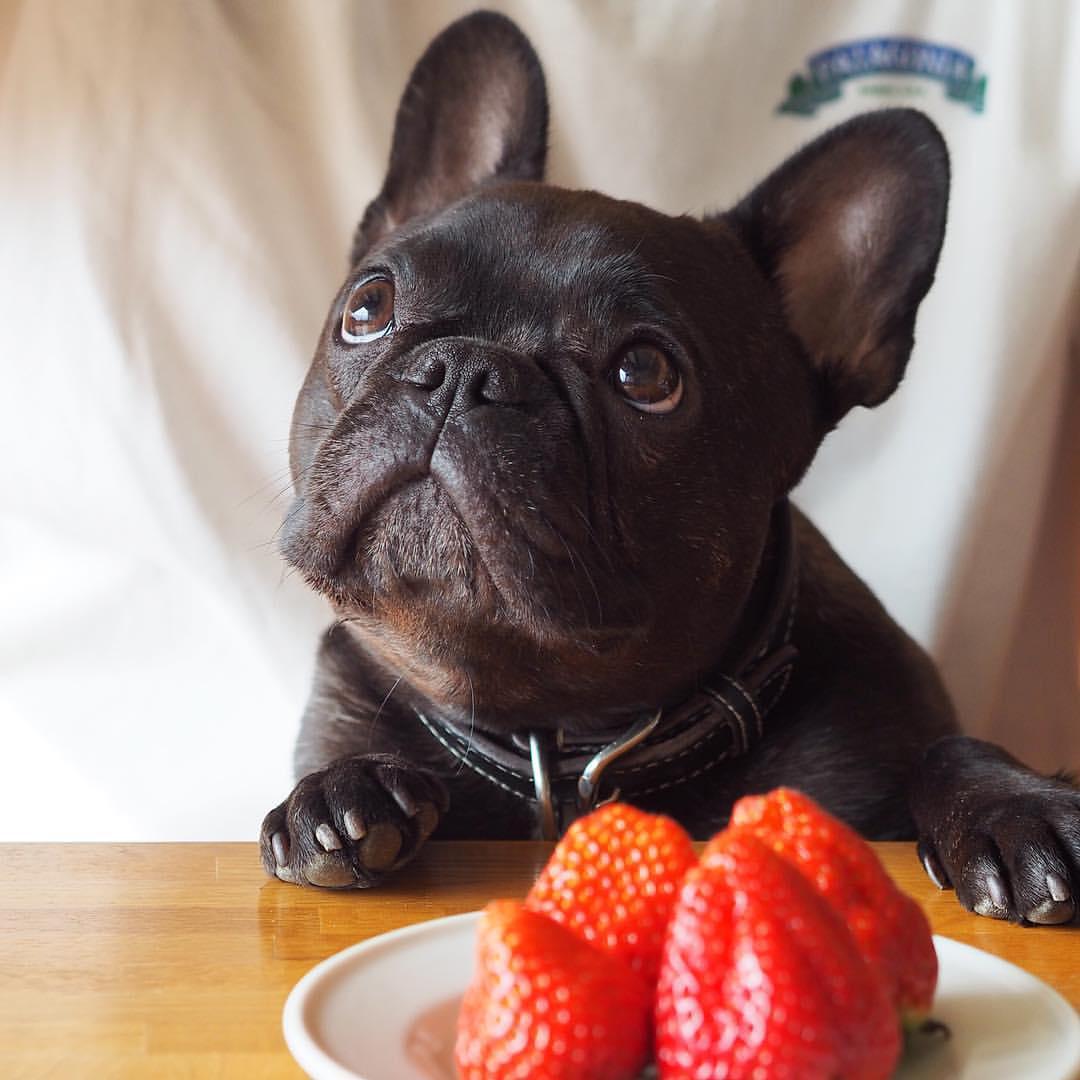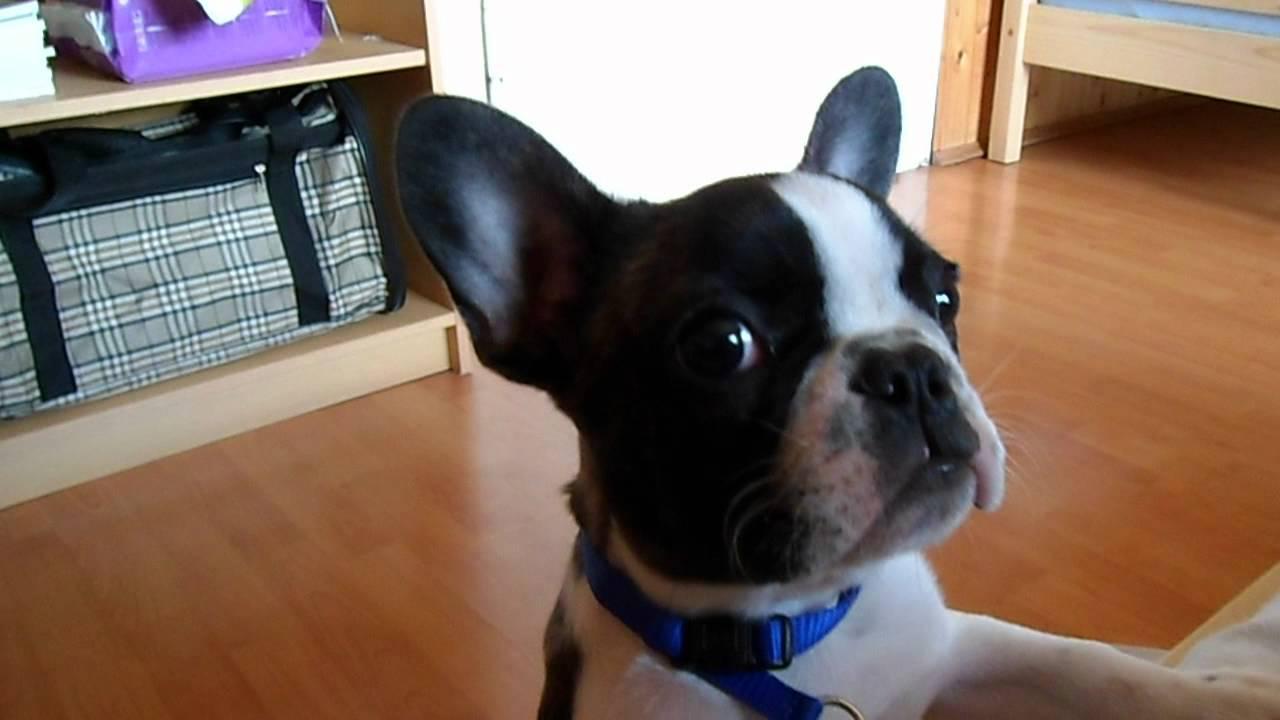The first image is the image on the left, the second image is the image on the right. For the images displayed, is the sentence "One image features a dog next to a half-peeled banana." factually correct? Answer yes or no. No. The first image is the image on the left, the second image is the image on the right. Analyze the images presented: Is the assertion "One image shows a dog with its face near a peeled banana shape." valid? Answer yes or no. No. 